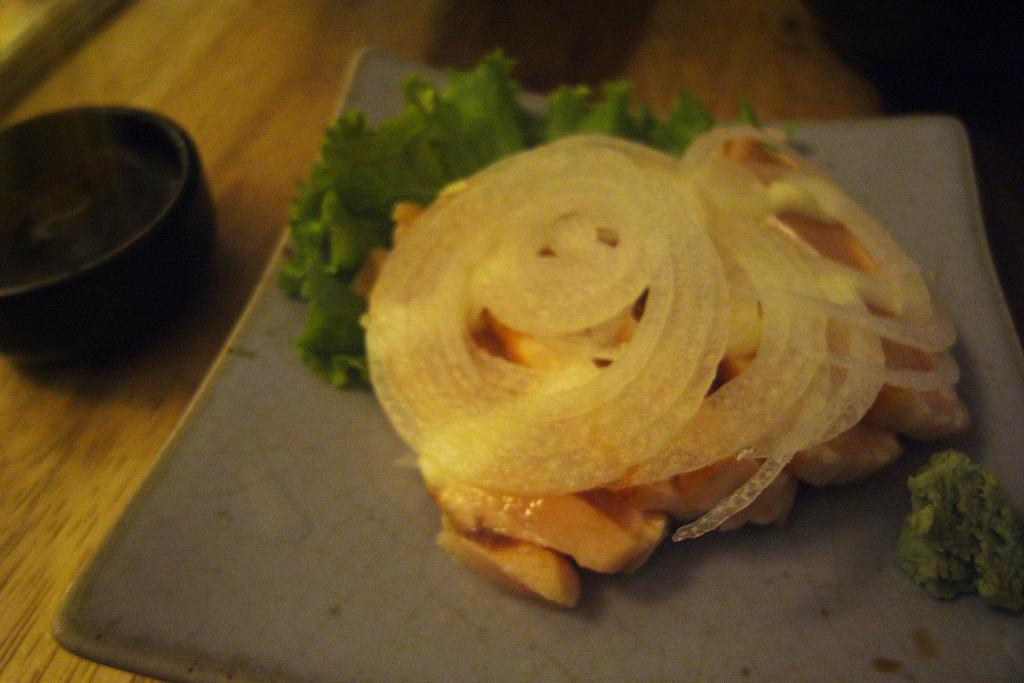What is placed on the table in the image? There is a plate placed on a table. What is on the plate? There is food on the plate. What is located to the left of the plate? There is a bowl to the left of the plate. What type of approval does the food on the plate need to receive in order to be considered delicious? There is no indication in the image that the food on the plate needs approval to be considered delicious. 